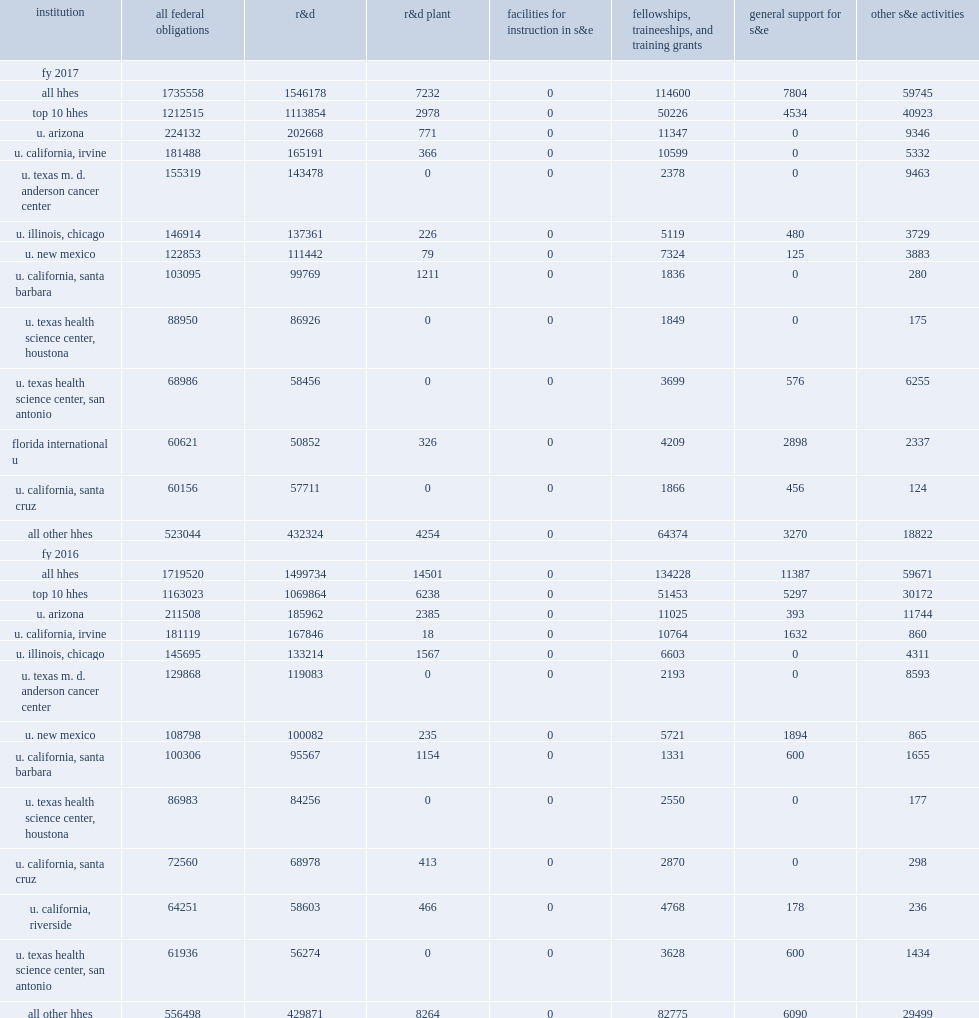Among other minority-serving institutions, how many thousand dollars did high-hispanic-enrollment institutions receive in federal obligations for s&e support in fy 2017? 1735558.0. Among other minority-serving institutions, high-hispanic-enrollment institutions (hhes) received $1.7 billion in federal obligations for s&e support in fy 2017, how many percentage points of increasing from fy 2016? 0.009327. How many thousand dollars did support to hhes for r&d amount to in fy 2017? 1546178.0. Support to hhes for r&d amounted to $1.5 billion, how many percentage points were up from the fy 2016 total? 0.030968. How many percentage points did r&d obligations account of total federal s&e support to hhes? 0.890882. 